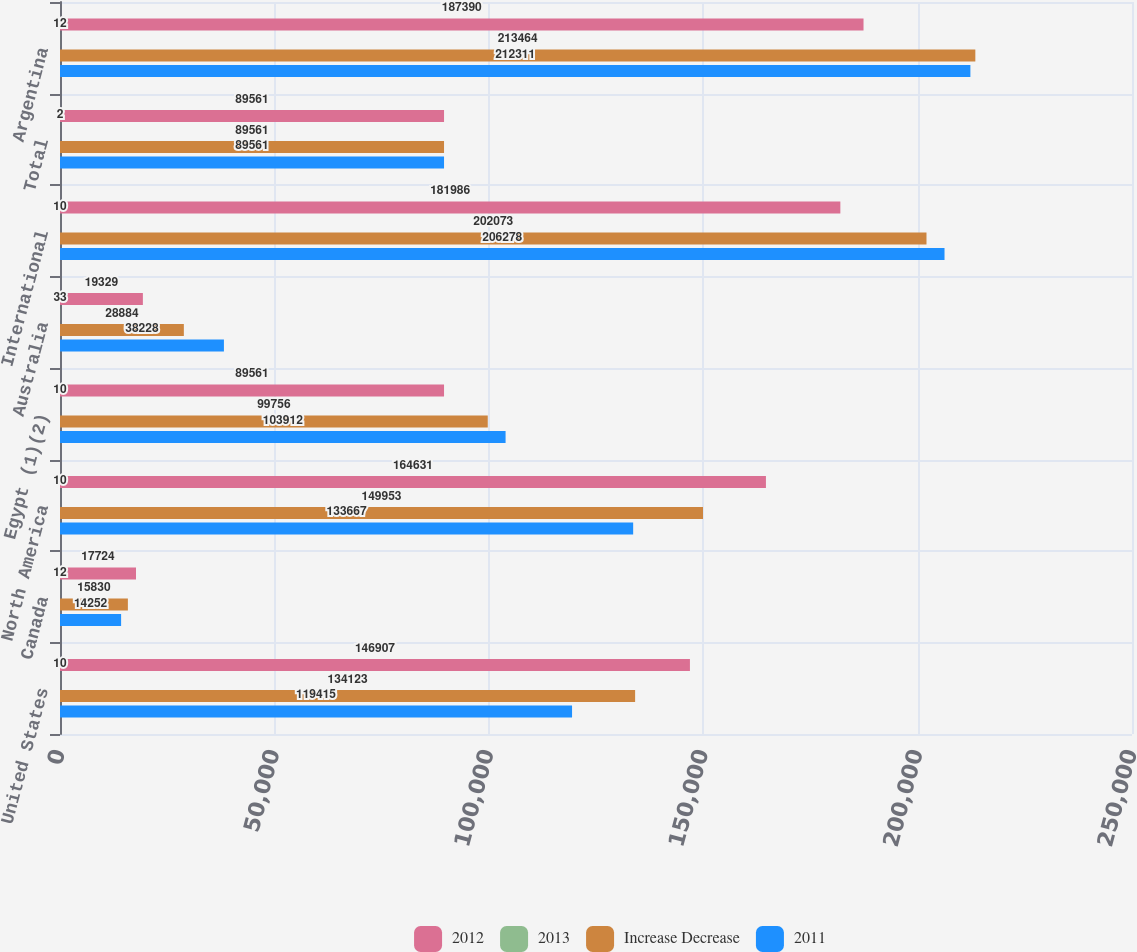Convert chart. <chart><loc_0><loc_0><loc_500><loc_500><stacked_bar_chart><ecel><fcel>United States<fcel>Canada<fcel>North America<fcel>Egypt (1)(2)<fcel>Australia<fcel>International<fcel>Total<fcel>Argentina<nl><fcel>2012<fcel>146907<fcel>17724<fcel>164631<fcel>89561<fcel>19329<fcel>181986<fcel>89561<fcel>187390<nl><fcel>2013<fcel>10<fcel>12<fcel>10<fcel>10<fcel>33<fcel>10<fcel>2<fcel>12<nl><fcel>Increase Decrease<fcel>134123<fcel>15830<fcel>149953<fcel>99756<fcel>28884<fcel>202073<fcel>89561<fcel>213464<nl><fcel>2011<fcel>119415<fcel>14252<fcel>133667<fcel>103912<fcel>38228<fcel>206278<fcel>89561<fcel>212311<nl></chart> 